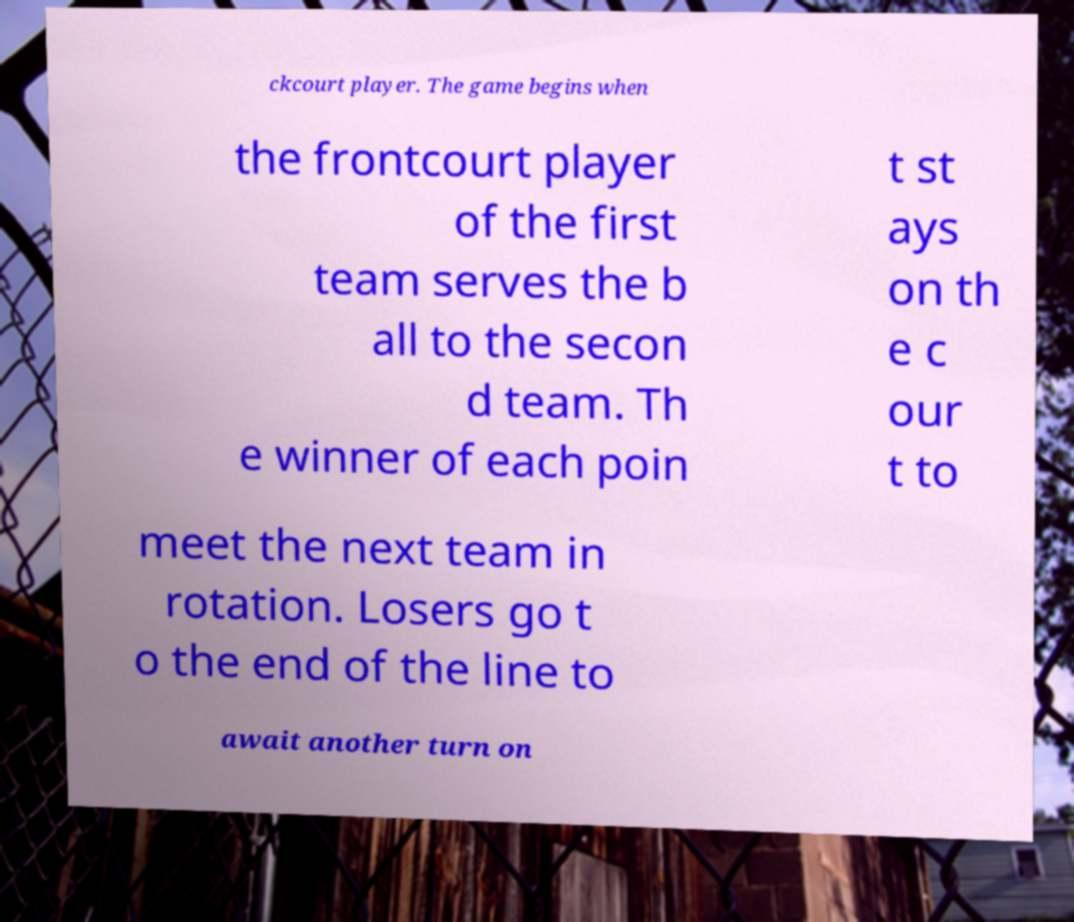For documentation purposes, I need the text within this image transcribed. Could you provide that? ckcourt player. The game begins when the frontcourt player of the first team serves the b all to the secon d team. Th e winner of each poin t st ays on th e c our t to meet the next team in rotation. Losers go t o the end of the line to await another turn on 